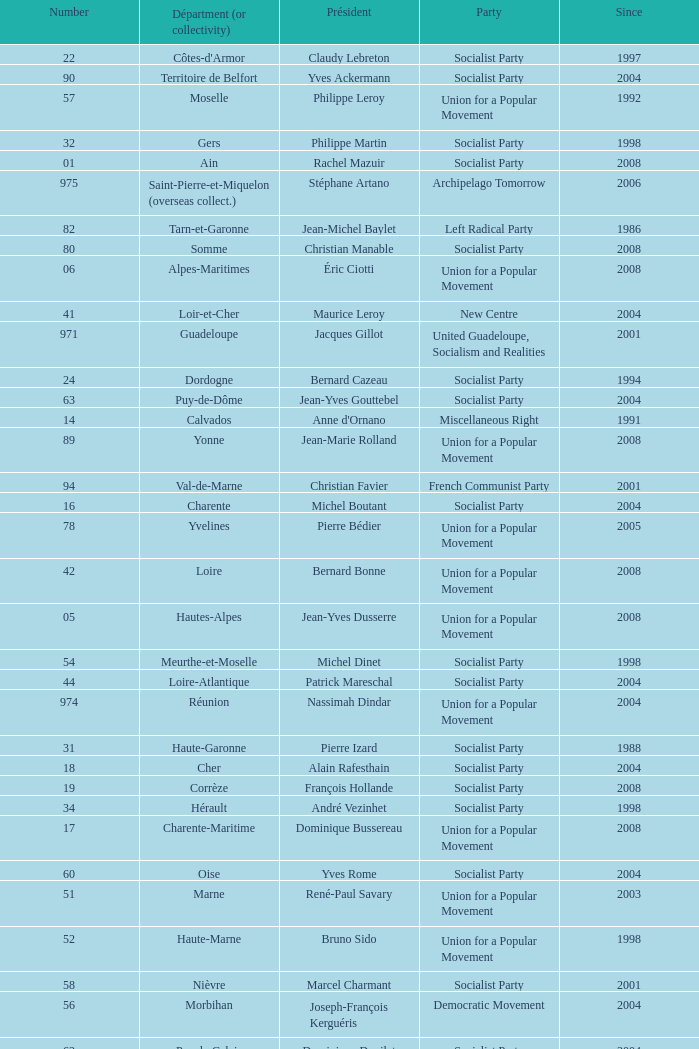Who is the president from the Union for a Popular Movement party that represents the Hautes-Alpes department? Jean-Yves Dusserre. 